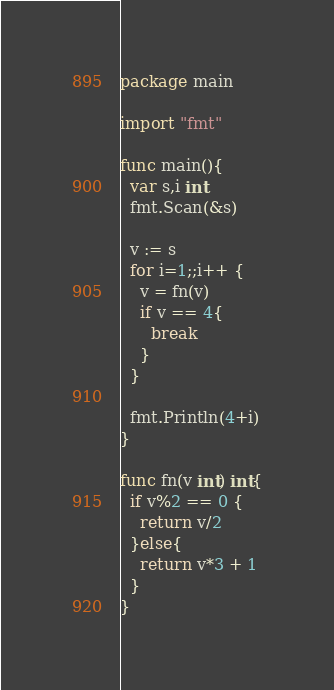Convert code to text. <code><loc_0><loc_0><loc_500><loc_500><_Go_>package main

import "fmt"

func main(){
  var s,i int
  fmt.Scan(&s)
  
  v := s
  for i=1;;i++ {
    v = fn(v)
    if v == 4{
      break
    }
  }
  
  fmt.Println(4+i)
}

func fn(v int) int{
  if v%2 == 0 {
    return v/2
  }else{
    return v*3 + 1
  }
}</code> 